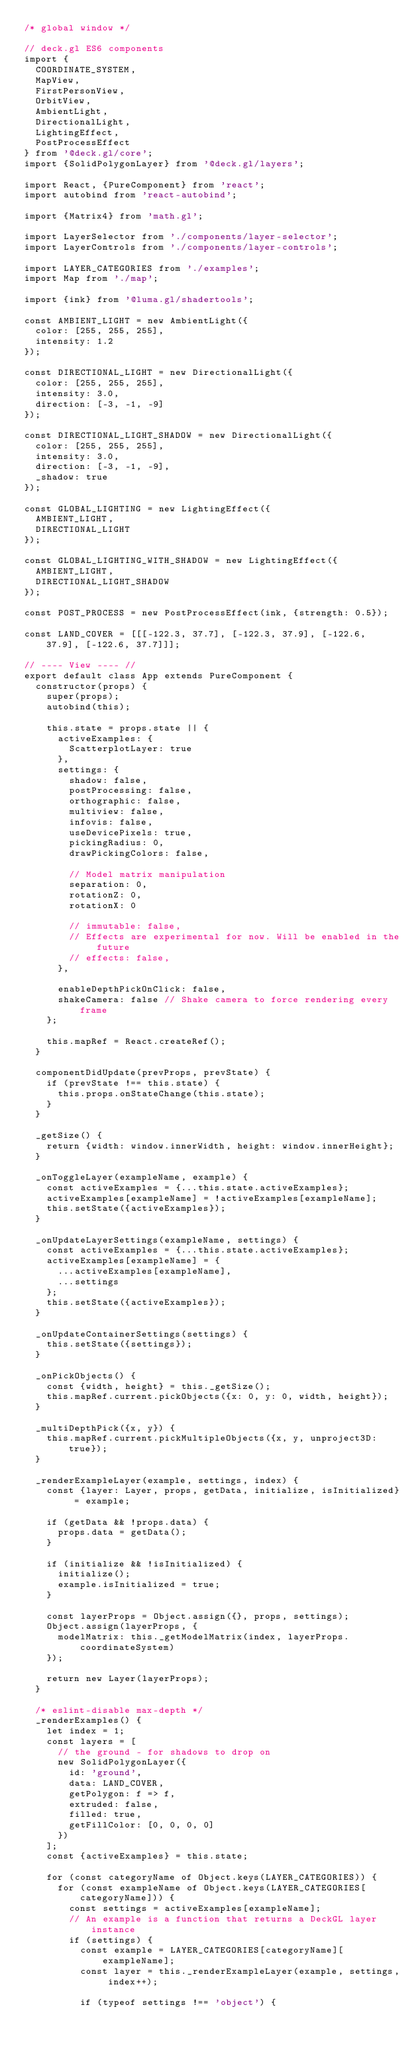Convert code to text. <code><loc_0><loc_0><loc_500><loc_500><_JavaScript_>/* global window */

// deck.gl ES6 components
import {
  COORDINATE_SYSTEM,
  MapView,
  FirstPersonView,
  OrbitView,
  AmbientLight,
  DirectionalLight,
  LightingEffect,
  PostProcessEffect
} from '@deck.gl/core';
import {SolidPolygonLayer} from '@deck.gl/layers';

import React, {PureComponent} from 'react';
import autobind from 'react-autobind';

import {Matrix4} from 'math.gl';

import LayerSelector from './components/layer-selector';
import LayerControls from './components/layer-controls';

import LAYER_CATEGORIES from './examples';
import Map from './map';

import {ink} from '@luma.gl/shadertools';

const AMBIENT_LIGHT = new AmbientLight({
  color: [255, 255, 255],
  intensity: 1.2
});

const DIRECTIONAL_LIGHT = new DirectionalLight({
  color: [255, 255, 255],
  intensity: 3.0,
  direction: [-3, -1, -9]
});

const DIRECTIONAL_LIGHT_SHADOW = new DirectionalLight({
  color: [255, 255, 255],
  intensity: 3.0,
  direction: [-3, -1, -9],
  _shadow: true
});

const GLOBAL_LIGHTING = new LightingEffect({
  AMBIENT_LIGHT,
  DIRECTIONAL_LIGHT
});

const GLOBAL_LIGHTING_WITH_SHADOW = new LightingEffect({
  AMBIENT_LIGHT,
  DIRECTIONAL_LIGHT_SHADOW
});

const POST_PROCESS = new PostProcessEffect(ink, {strength: 0.5});

const LAND_COVER = [[[-122.3, 37.7], [-122.3, 37.9], [-122.6, 37.9], [-122.6, 37.7]]];

// ---- View ---- //
export default class App extends PureComponent {
  constructor(props) {
    super(props);
    autobind(this);

    this.state = props.state || {
      activeExamples: {
        ScatterplotLayer: true
      },
      settings: {
        shadow: false,
        postProcessing: false,
        orthographic: false,
        multiview: false,
        infovis: false,
        useDevicePixels: true,
        pickingRadius: 0,
        drawPickingColors: false,

        // Model matrix manipulation
        separation: 0,
        rotationZ: 0,
        rotationX: 0

        // immutable: false,
        // Effects are experimental for now. Will be enabled in the future
        // effects: false,
      },

      enableDepthPickOnClick: false,
      shakeCamera: false // Shake camera to force rendering every frame
    };

    this.mapRef = React.createRef();
  }

  componentDidUpdate(prevProps, prevState) {
    if (prevState !== this.state) {
      this.props.onStateChange(this.state);
    }
  }

  _getSize() {
    return {width: window.innerWidth, height: window.innerHeight};
  }

  _onToggleLayer(exampleName, example) {
    const activeExamples = {...this.state.activeExamples};
    activeExamples[exampleName] = !activeExamples[exampleName];
    this.setState({activeExamples});
  }

  _onUpdateLayerSettings(exampleName, settings) {
    const activeExamples = {...this.state.activeExamples};
    activeExamples[exampleName] = {
      ...activeExamples[exampleName],
      ...settings
    };
    this.setState({activeExamples});
  }

  _onUpdateContainerSettings(settings) {
    this.setState({settings});
  }

  _onPickObjects() {
    const {width, height} = this._getSize();
    this.mapRef.current.pickObjects({x: 0, y: 0, width, height});
  }

  _multiDepthPick({x, y}) {
    this.mapRef.current.pickMultipleObjects({x, y, unproject3D: true});
  }

  _renderExampleLayer(example, settings, index) {
    const {layer: Layer, props, getData, initialize, isInitialized} = example;

    if (getData && !props.data) {
      props.data = getData();
    }

    if (initialize && !isInitialized) {
      initialize();
      example.isInitialized = true;
    }

    const layerProps = Object.assign({}, props, settings);
    Object.assign(layerProps, {
      modelMatrix: this._getModelMatrix(index, layerProps.coordinateSystem)
    });

    return new Layer(layerProps);
  }

  /* eslint-disable max-depth */
  _renderExamples() {
    let index = 1;
    const layers = [
      // the ground - for shadows to drop on
      new SolidPolygonLayer({
        id: 'ground',
        data: LAND_COVER,
        getPolygon: f => f,
        extruded: false,
        filled: true,
        getFillColor: [0, 0, 0, 0]
      })
    ];
    const {activeExamples} = this.state;

    for (const categoryName of Object.keys(LAYER_CATEGORIES)) {
      for (const exampleName of Object.keys(LAYER_CATEGORIES[categoryName])) {
        const settings = activeExamples[exampleName];
        // An example is a function that returns a DeckGL layer instance
        if (settings) {
          const example = LAYER_CATEGORIES[categoryName][exampleName];
          const layer = this._renderExampleLayer(example, settings, index++);

          if (typeof settings !== 'object') {</code> 